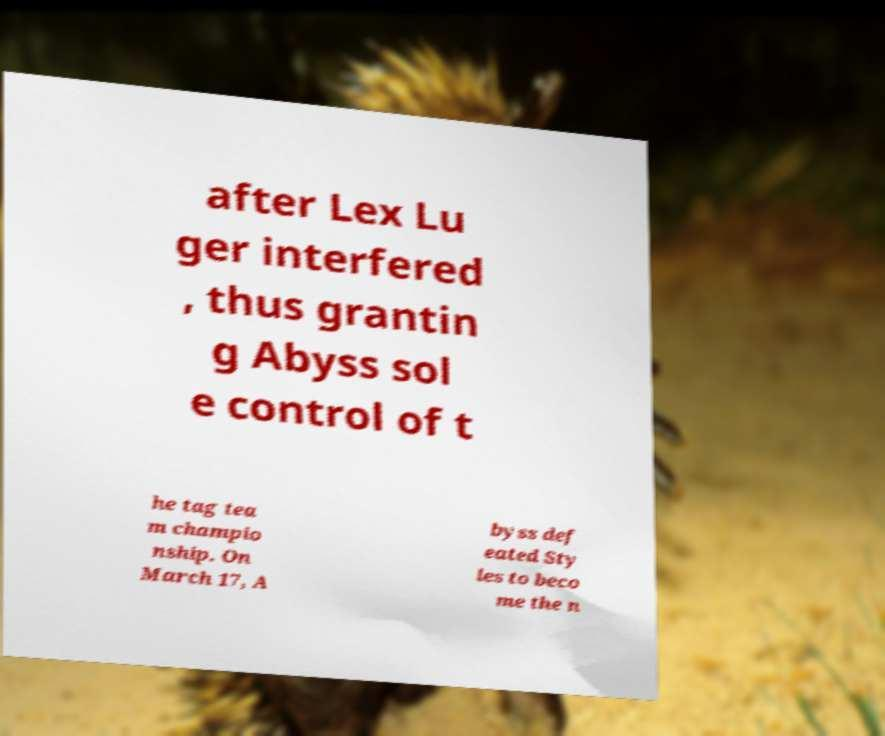Could you extract and type out the text from this image? after Lex Lu ger interfered , thus grantin g Abyss sol e control of t he tag tea m champio nship. On March 17, A byss def eated Sty les to beco me the n 